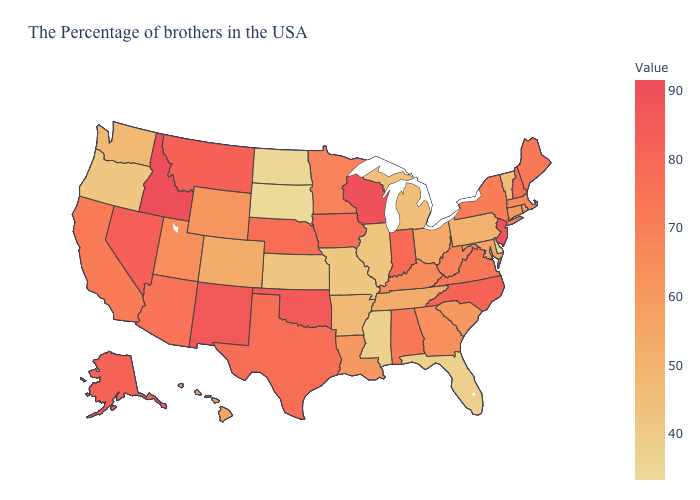Which states have the highest value in the USA?
Quick response, please. Idaho. Among the states that border Delaware , which have the highest value?
Concise answer only. New Jersey. Does the map have missing data?
Concise answer only. No. Does South Carolina have a lower value than New Mexico?
Be succinct. Yes. 